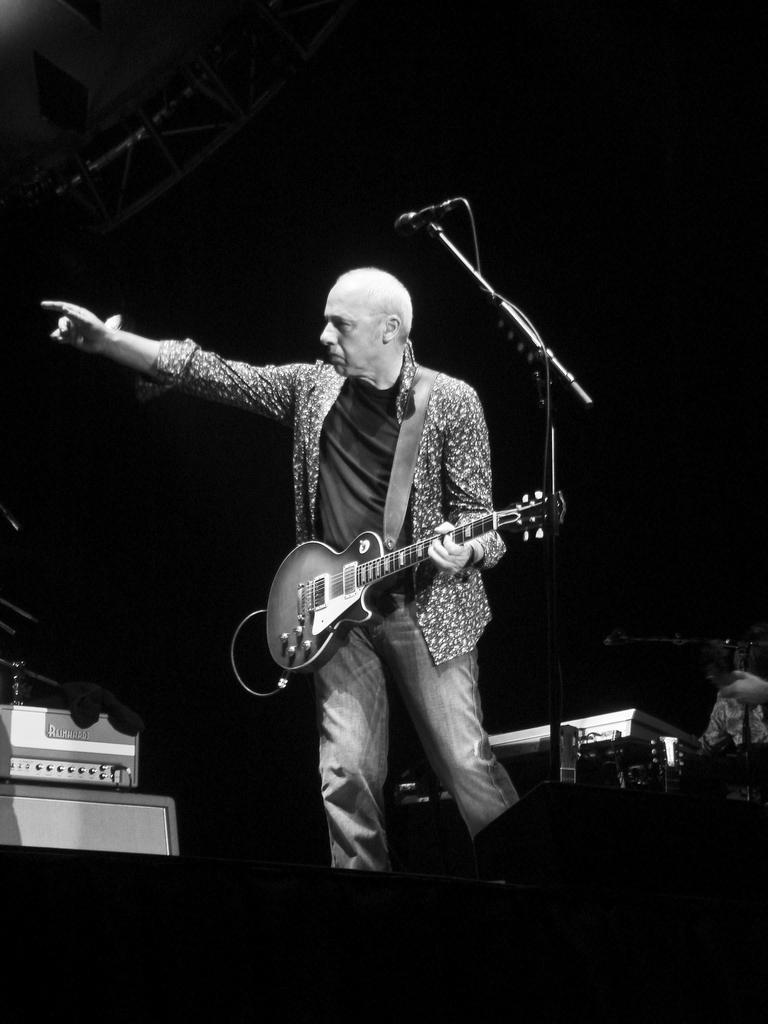Can you describe this image briefly? In this image I can see a person standing in front of the mic and holding the guitar. 